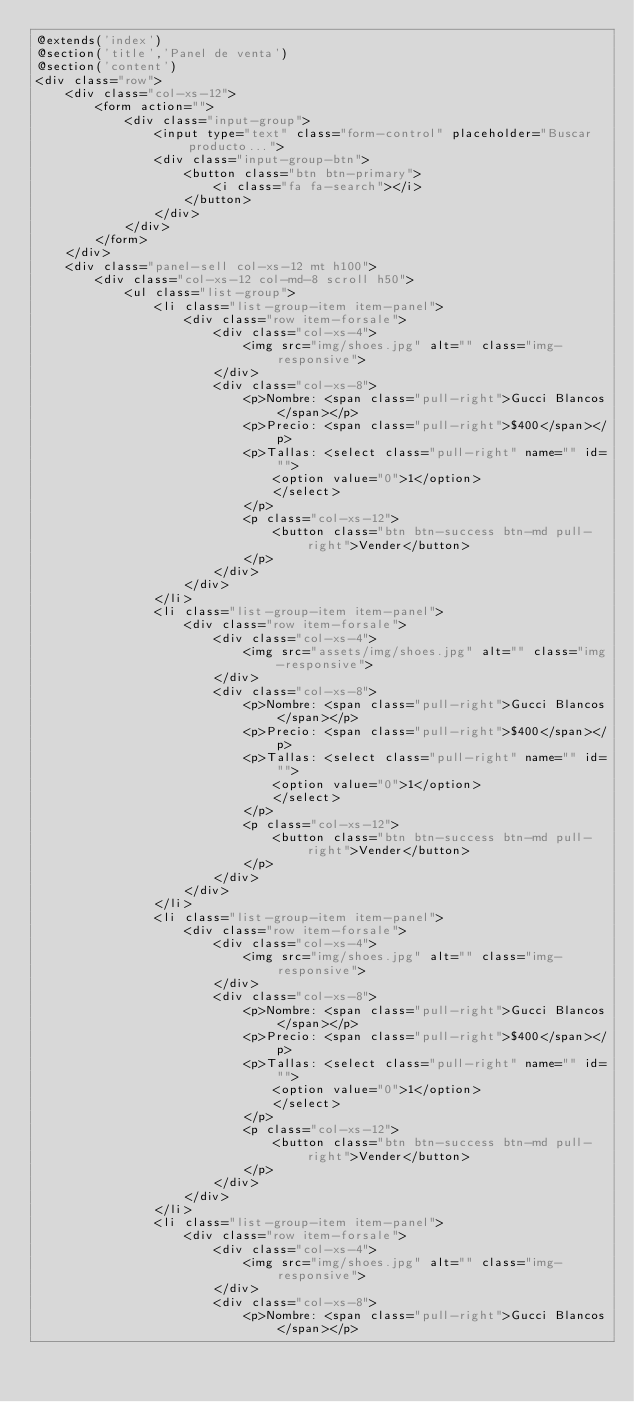Convert code to text. <code><loc_0><loc_0><loc_500><loc_500><_PHP_>@extends('index')
@section('title','Panel de venta')
@section('content')
<div class="row">
    <div class="col-xs-12">
        <form action="">
            <div class="input-group">
                <input type="text" class="form-control" placeholder="Buscar producto...">
                <div class="input-group-btn">
                    <button class="btn btn-primary">
                        <i class="fa fa-search"></i>
                    </button>
                </div>
            </div>
        </form>
    </div>
    <div class="panel-sell col-xs-12 mt h100">
        <div class="col-xs-12 col-md-8 scroll h50">
            <ul class="list-group">
                <li class="list-group-item item-panel">
                    <div class="row item-forsale">
                        <div class="col-xs-4">
                            <img src="img/shoes.jpg" alt="" class="img-responsive">
                        </div>
                        <div class="col-xs-8">
                            <p>Nombre: <span class="pull-right">Gucci Blancos</span></p>
                            <p>Precio: <span class="pull-right">$400</span></p>
                            <p>Tallas: <select class="pull-right" name="" id="">
                                <option value="0">1</option>
                                </select>
                            </p>
                            <p class="col-xs-12">
                                <button class="btn btn-success btn-md pull-right">Vender</button>
                            </p>
                        </div>
                    </div>
                </li>
                <li class="list-group-item item-panel">
                    <div class="row item-forsale">
                        <div class="col-xs-4">
                            <img src="assets/img/shoes.jpg" alt="" class="img-responsive">
                        </div>
                        <div class="col-xs-8">
                            <p>Nombre: <span class="pull-right">Gucci Blancos</span></p>
                            <p>Precio: <span class="pull-right">$400</span></p>
                            <p>Tallas: <select class="pull-right" name="" id="">
                                <option value="0">1</option>
                                </select>
                            </p>
                            <p class="col-xs-12">
                                <button class="btn btn-success btn-md pull-right">Vender</button>
                            </p>
                        </div>
                    </div>
                </li>
                <li class="list-group-item item-panel">
                    <div class="row item-forsale">
                        <div class="col-xs-4">
                            <img src="img/shoes.jpg" alt="" class="img-responsive">
                        </div>
                        <div class="col-xs-8">
                            <p>Nombre: <span class="pull-right">Gucci Blancos</span></p>
                            <p>Precio: <span class="pull-right">$400</span></p>
                            <p>Tallas: <select class="pull-right" name="" id="">
                                <option value="0">1</option>
                                </select>
                            </p>
                            <p class="col-xs-12">
                                <button class="btn btn-success btn-md pull-right">Vender</button>
                            </p>
                        </div>
                    </div>
                </li>
                <li class="list-group-item item-panel">
                    <div class="row item-forsale">
                        <div class="col-xs-4">
                            <img src="img/shoes.jpg" alt="" class="img-responsive">
                        </div>
                        <div class="col-xs-8">
                            <p>Nombre: <span class="pull-right">Gucci Blancos</span></p></code> 